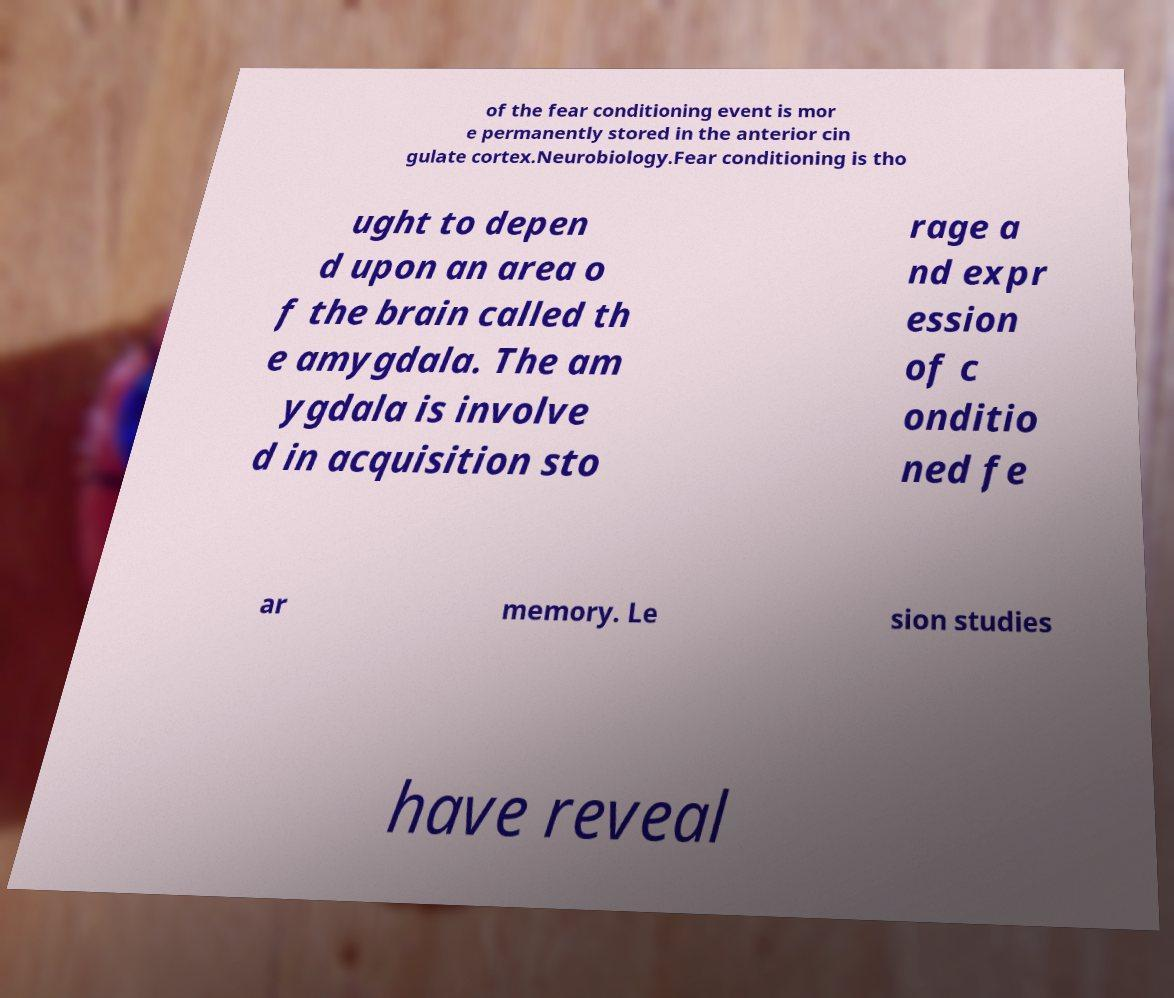Please identify and transcribe the text found in this image. of the fear conditioning event is mor e permanently stored in the anterior cin gulate cortex.Neurobiology.Fear conditioning is tho ught to depen d upon an area o f the brain called th e amygdala. The am ygdala is involve d in acquisition sto rage a nd expr ession of c onditio ned fe ar memory. Le sion studies have reveal 